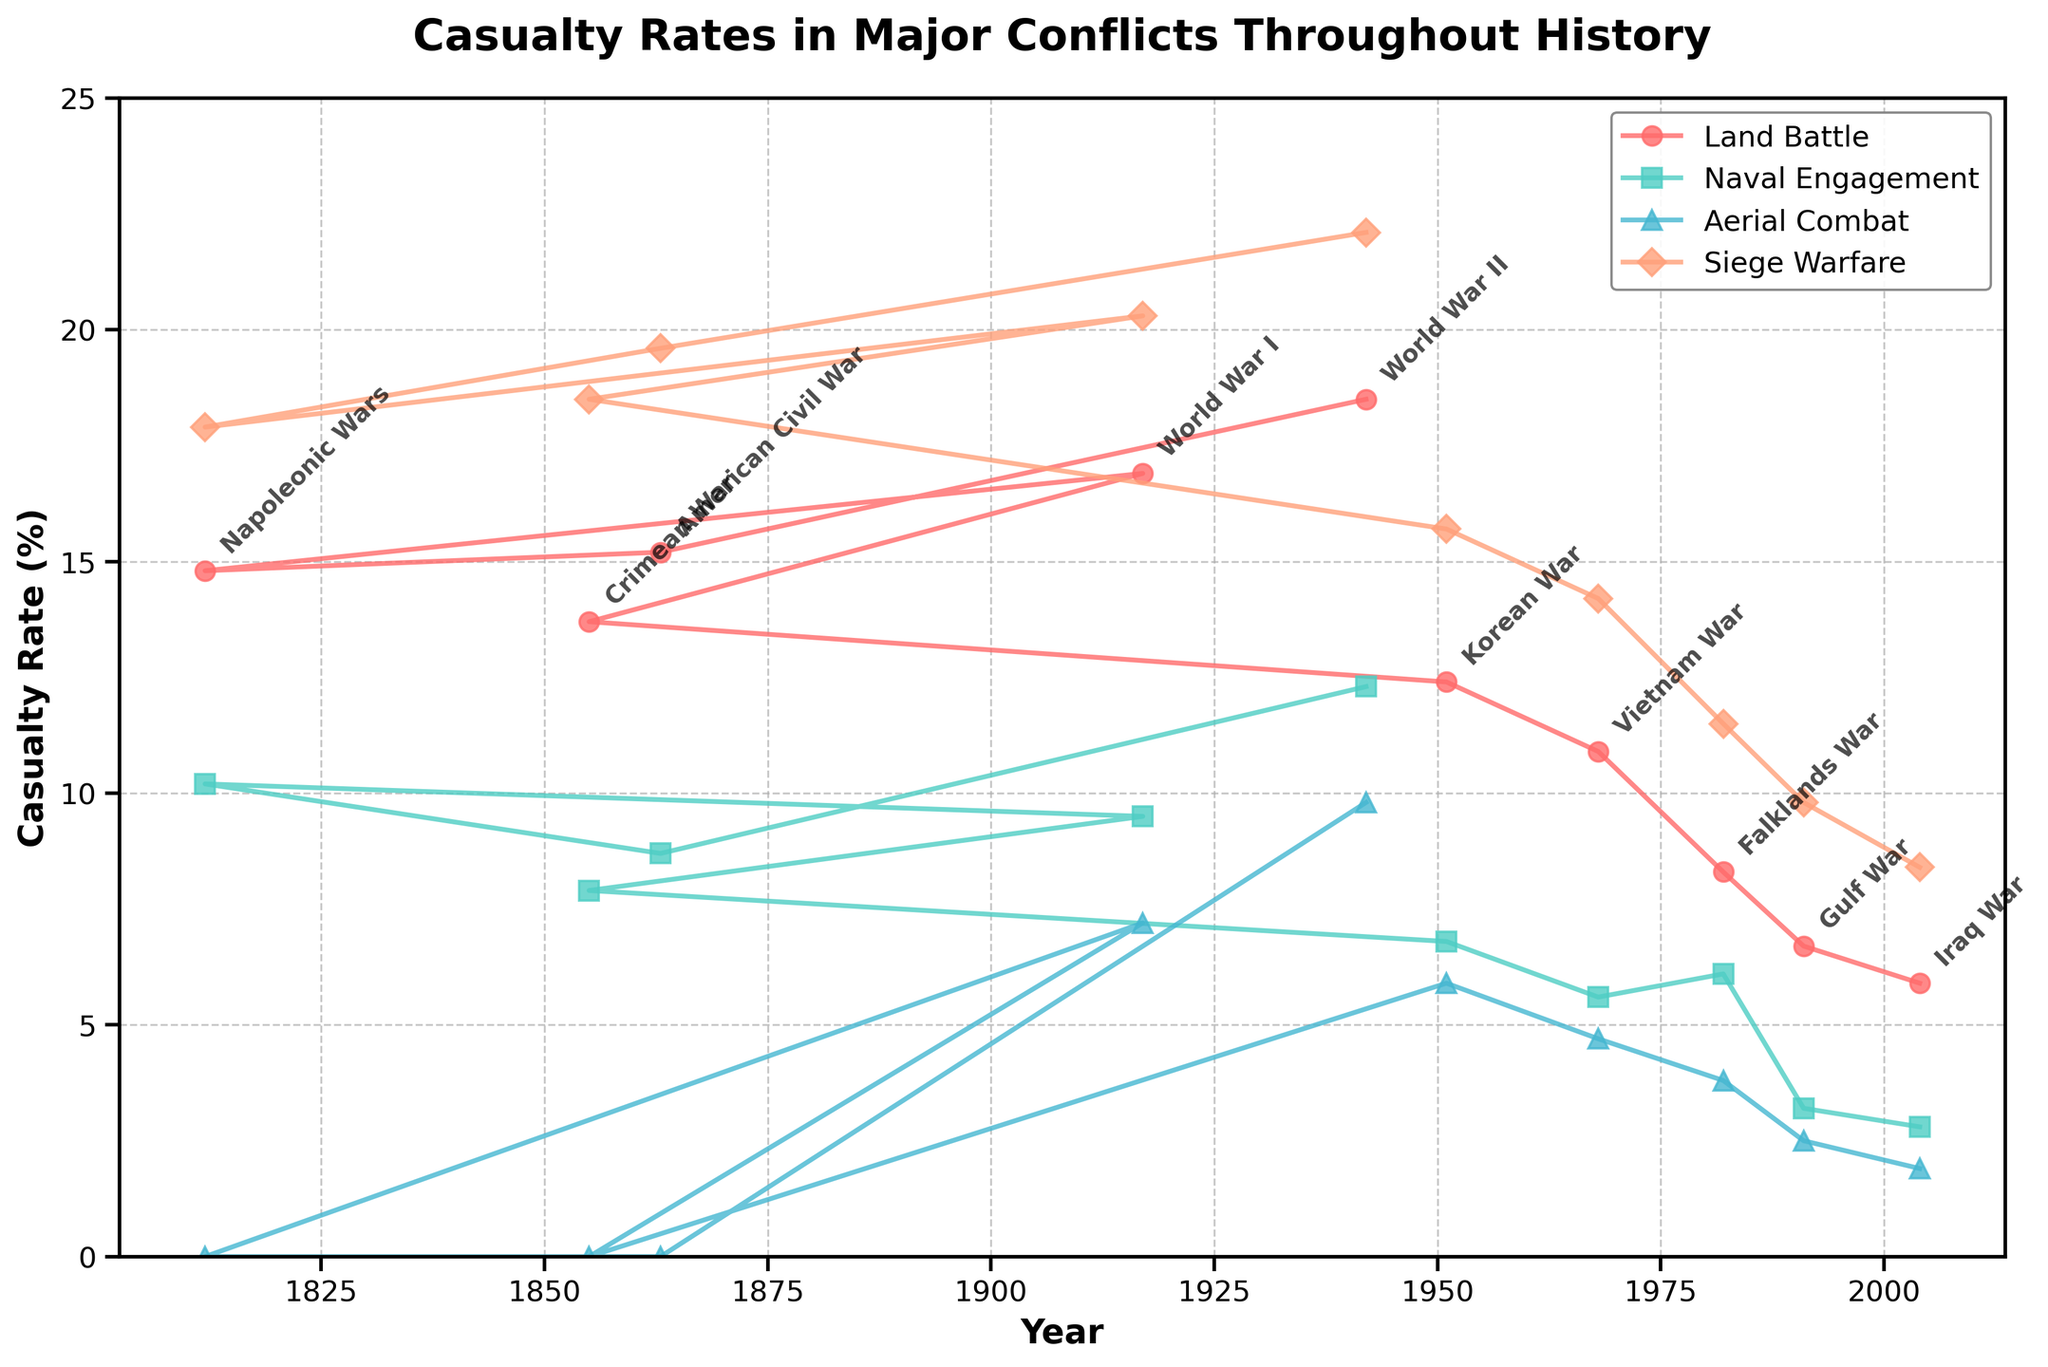What's the highest casualty rate displayed for Land Battle conflicts? The highest point on the 'Land Battle' line in the plot indicates the highest casualty rate. The peak appears in 1942 during World War II.
Answer: 18.5% Compare the casualty rates between Naval Engagement and Aerial Combat during World War I. Which type had higher casualty rates in 1917? Locate the year 1917 on the x-axis and compare the corresponding points for 'Naval Engagement' and 'Aerial Combat'. The 'Naval Engagement' is at 9.5% and the 'Aerial Combat' is at 7.2%.
Answer: Naval Engagement During which conflict did Siege Warfare have the smallest casualty rate according to the figure? Find the lowest point on the 'Siege Warfare' line. The smallest casualty rate appears in 2004 during the Iraq War.
Answer: Iraq War (2004) Calculate the average casualty rate for Land Battle over all conflicts provided. Add all the values for 'Land Battle' and divide by the number of conflicts: (18.5 + 15.2 + 14.8 + 16.9 + 13.7 + 12.4 + 10.9 + 8.3 + 6.7 + 5.9) / 10.
Answer: 12.33% Which conflict shows the greatest difference between Land Battle and Naval Engagement casualty rates? For each conflict, calculate the absolute difference between 'Land Battle' and 'Naval Engagement' rates and identify the highest difference. For World War II (1942):
Answer: 6.2% How did the casualty rates for Aerial Combat change from World War I to World War II? Compare the values for 'Aerial Combat' in 1917 (World War I) and 1942 (World War II). The values are 7.2% and 9.8%, respectively, indicating an increase.
Answer: Increased Which engagement type had a declining trend throughout the years shown in the figure? Look at the slope or direction of each line over time. 'Land Battle', 'Naval Engagement', and 'Siege Warfare' generally show a declining trend, while 'Aerial Combat' is less clear.
Answer: Land Battle Determine the conflict year that had the closest casualty rates for Land Battle and Siege Warfare. Identify when the 'Land Battle' and 'Siege Warfare' lines are closest together. The closest values are during the Korean War (1951), where the values are 12.4% for 'Land Battle' and 15.7% for 'Siege Warfare'.
Answer: Korean War (1951) What color is used to represent Siege Warfare in the chart? Based on the legend in the plot, Siege Warfare is represented by an orange color.
Answer: Orange Identify the conflict with the most balanced casualty rates across all types of engagements. Look for the conflict where lines are closest together. For 1951 (Korean War), values are 12.4% (Land Battle), 6.8% (Naval Engagement), 5.9% (Aerial Combat), and 15.7% (Siege Warfare), showing the most balance.
Answer: Korean War (1951) 